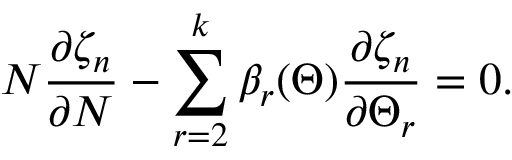Convert formula to latex. <formula><loc_0><loc_0><loc_500><loc_500>N \frac { \partial \zeta _ { n } } { \partial N } - \sum _ { r = 2 } ^ { k } \beta _ { r } ( \Theta ) \frac { \partial \zeta _ { n } } { \partial \Theta _ { r } } = 0 .</formula> 